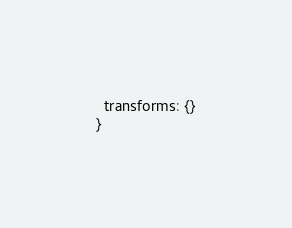Convert code to text. <code><loc_0><loc_0><loc_500><loc_500><_JavaScript_>  transforms: {}
}</code> 